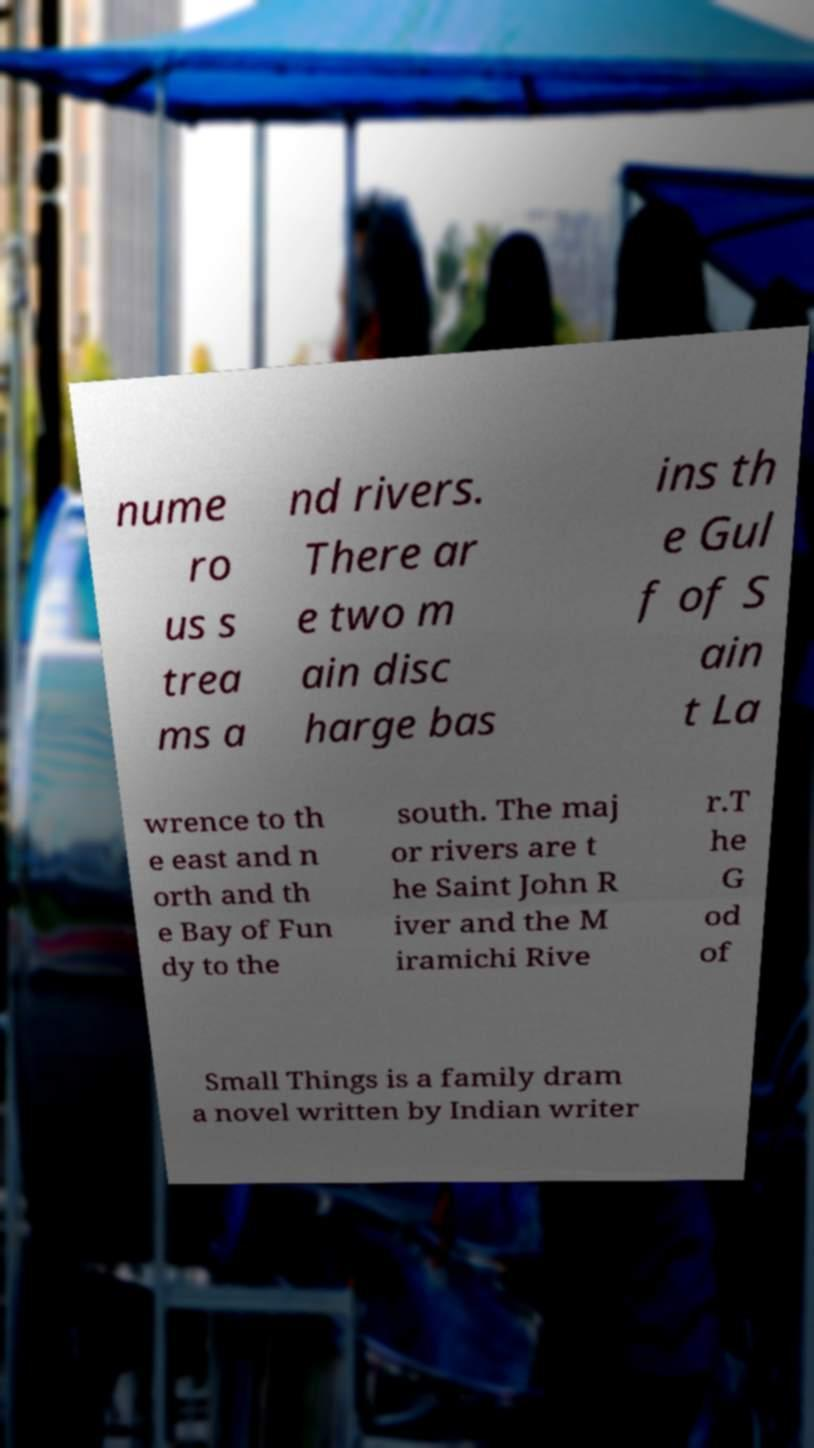Could you extract and type out the text from this image? nume ro us s trea ms a nd rivers. There ar e two m ain disc harge bas ins th e Gul f of S ain t La wrence to th e east and n orth and th e Bay of Fun dy to the south. The maj or rivers are t he Saint John R iver and the M iramichi Rive r.T he G od of Small Things is a family dram a novel written by Indian writer 